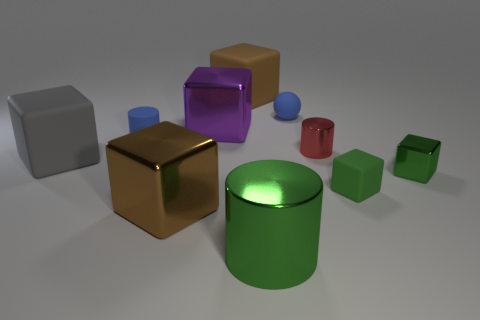What material is the other brown thing that is the same shape as the big brown metal thing?
Your answer should be compact. Rubber. Is there any other thing that is made of the same material as the large green thing?
Provide a short and direct response. Yes. What number of blocks are gray matte things or small matte objects?
Give a very brief answer. 2. Does the blue object that is on the right side of the big cylinder have the same size as the brown block that is in front of the blue matte ball?
Offer a terse response. No. There is a purple thing left of the blue object right of the large green metal thing; what is it made of?
Offer a terse response. Metal. Are there fewer green objects in front of the small green matte cube than green shiny cylinders?
Your answer should be very brief. No. What is the shape of the brown thing that is the same material as the large purple cube?
Ensure brevity in your answer.  Cube. How many other things are there of the same shape as the purple metallic thing?
Provide a short and direct response. 5. What number of purple things are cubes or balls?
Provide a short and direct response. 1. Is the gray matte thing the same shape as the tiny red object?
Your answer should be very brief. No. 